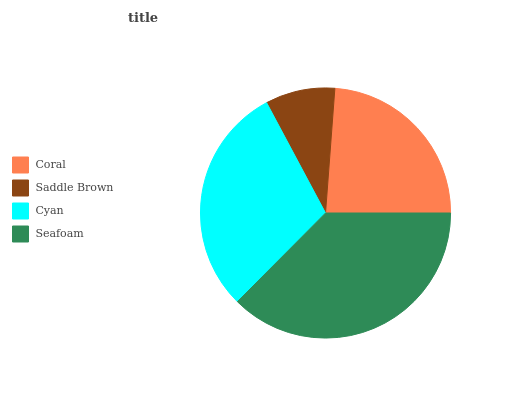Is Saddle Brown the minimum?
Answer yes or no. Yes. Is Seafoam the maximum?
Answer yes or no. Yes. Is Cyan the minimum?
Answer yes or no. No. Is Cyan the maximum?
Answer yes or no. No. Is Cyan greater than Saddle Brown?
Answer yes or no. Yes. Is Saddle Brown less than Cyan?
Answer yes or no. Yes. Is Saddle Brown greater than Cyan?
Answer yes or no. No. Is Cyan less than Saddle Brown?
Answer yes or no. No. Is Cyan the high median?
Answer yes or no. Yes. Is Coral the low median?
Answer yes or no. Yes. Is Coral the high median?
Answer yes or no. No. Is Seafoam the low median?
Answer yes or no. No. 